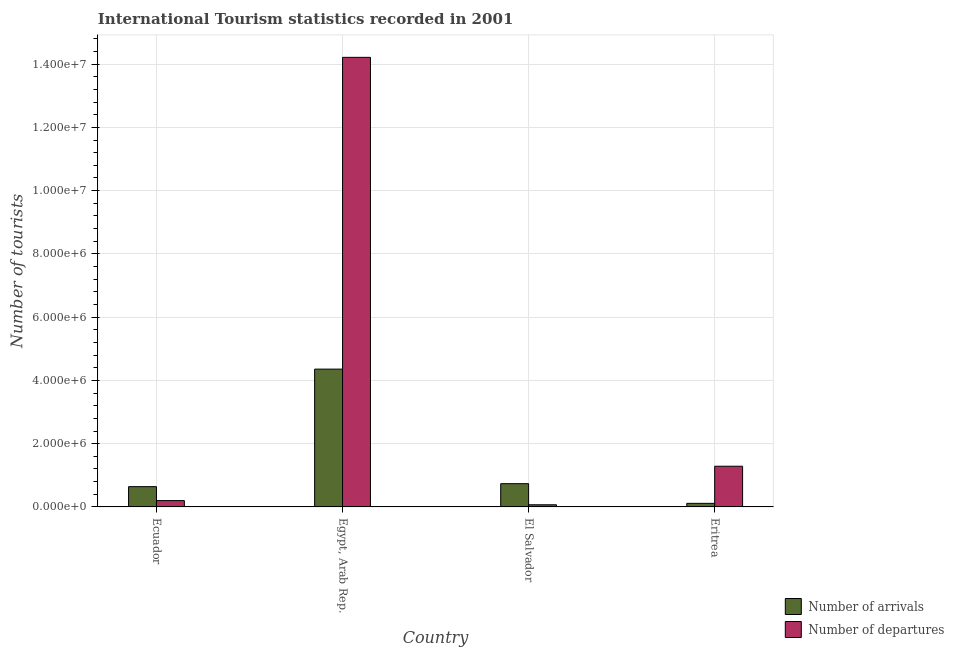How many different coloured bars are there?
Provide a succinct answer. 2. Are the number of bars on each tick of the X-axis equal?
Your answer should be compact. Yes. How many bars are there on the 4th tick from the left?
Give a very brief answer. 2. How many bars are there on the 4th tick from the right?
Make the answer very short. 2. What is the label of the 4th group of bars from the left?
Offer a terse response. Eritrea. What is the number of tourist arrivals in Ecuador?
Provide a short and direct response. 6.41e+05. Across all countries, what is the maximum number of tourist departures?
Provide a succinct answer. 1.42e+07. Across all countries, what is the minimum number of tourist arrivals?
Keep it short and to the point. 1.13e+05. In which country was the number of tourist departures maximum?
Your answer should be very brief. Egypt, Arab Rep. In which country was the number of tourist departures minimum?
Make the answer very short. El Salvador. What is the total number of tourist departures in the graph?
Make the answer very short. 1.58e+07. What is the difference between the number of tourist arrivals in Egypt, Arab Rep. and that in Eritrea?
Give a very brief answer. 4.24e+06. What is the difference between the number of tourist departures in Eritrea and the number of tourist arrivals in Egypt, Arab Rep.?
Keep it short and to the point. -3.07e+06. What is the average number of tourist arrivals per country?
Your answer should be compact. 1.46e+06. What is the difference between the number of tourist departures and number of tourist arrivals in El Salvador?
Give a very brief answer. -6.67e+05. In how many countries, is the number of tourist arrivals greater than 12400000 ?
Make the answer very short. 0. What is the ratio of the number of tourist arrivals in Egypt, Arab Rep. to that in Eritrea?
Provide a succinct answer. 38.56. Is the difference between the number of tourist arrivals in Egypt, Arab Rep. and Eritrea greater than the difference between the number of tourist departures in Egypt, Arab Rep. and Eritrea?
Make the answer very short. No. What is the difference between the highest and the second highest number of tourist departures?
Make the answer very short. 1.29e+07. What is the difference between the highest and the lowest number of tourist arrivals?
Offer a terse response. 4.24e+06. What does the 2nd bar from the left in Egypt, Arab Rep. represents?
Ensure brevity in your answer.  Number of departures. What does the 1st bar from the right in Eritrea represents?
Your response must be concise. Number of departures. How many bars are there?
Ensure brevity in your answer.  8. How many countries are there in the graph?
Provide a succinct answer. 4. Does the graph contain any zero values?
Give a very brief answer. No. Does the graph contain grids?
Ensure brevity in your answer.  Yes. How many legend labels are there?
Offer a very short reply. 2. How are the legend labels stacked?
Offer a very short reply. Vertical. What is the title of the graph?
Provide a succinct answer. International Tourism statistics recorded in 2001. Does "From production" appear as one of the legend labels in the graph?
Provide a short and direct response. No. What is the label or title of the Y-axis?
Ensure brevity in your answer.  Number of tourists. What is the Number of tourists in Number of arrivals in Ecuador?
Ensure brevity in your answer.  6.41e+05. What is the Number of tourists in Number of arrivals in Egypt, Arab Rep.?
Your response must be concise. 4.36e+06. What is the Number of tourists in Number of departures in Egypt, Arab Rep.?
Your response must be concise. 1.42e+07. What is the Number of tourists in Number of arrivals in El Salvador?
Offer a very short reply. 7.35e+05. What is the Number of tourists in Number of departures in El Salvador?
Your answer should be compact. 6.80e+04. What is the Number of tourists in Number of arrivals in Eritrea?
Give a very brief answer. 1.13e+05. What is the Number of tourists in Number of departures in Eritrea?
Offer a very short reply. 1.29e+06. Across all countries, what is the maximum Number of tourists in Number of arrivals?
Keep it short and to the point. 4.36e+06. Across all countries, what is the maximum Number of tourists of Number of departures?
Give a very brief answer. 1.42e+07. Across all countries, what is the minimum Number of tourists of Number of arrivals?
Make the answer very short. 1.13e+05. Across all countries, what is the minimum Number of tourists of Number of departures?
Provide a short and direct response. 6.80e+04. What is the total Number of tourists of Number of arrivals in the graph?
Offer a very short reply. 5.85e+06. What is the total Number of tourists in Number of departures in the graph?
Offer a very short reply. 1.58e+07. What is the difference between the Number of tourists of Number of arrivals in Ecuador and that in Egypt, Arab Rep.?
Your answer should be compact. -3.72e+06. What is the difference between the Number of tourists of Number of departures in Ecuador and that in Egypt, Arab Rep.?
Your response must be concise. -1.40e+07. What is the difference between the Number of tourists in Number of arrivals in Ecuador and that in El Salvador?
Make the answer very short. -9.40e+04. What is the difference between the Number of tourists of Number of departures in Ecuador and that in El Salvador?
Ensure brevity in your answer.  1.32e+05. What is the difference between the Number of tourists in Number of arrivals in Ecuador and that in Eritrea?
Offer a very short reply. 5.28e+05. What is the difference between the Number of tourists of Number of departures in Ecuador and that in Eritrea?
Keep it short and to the point. -1.09e+06. What is the difference between the Number of tourists of Number of arrivals in Egypt, Arab Rep. and that in El Salvador?
Your answer should be very brief. 3.62e+06. What is the difference between the Number of tourists of Number of departures in Egypt, Arab Rep. and that in El Salvador?
Offer a very short reply. 1.41e+07. What is the difference between the Number of tourists in Number of arrivals in Egypt, Arab Rep. and that in Eritrea?
Provide a succinct answer. 4.24e+06. What is the difference between the Number of tourists in Number of departures in Egypt, Arab Rep. and that in Eritrea?
Your answer should be very brief. 1.29e+07. What is the difference between the Number of tourists of Number of arrivals in El Salvador and that in Eritrea?
Provide a succinct answer. 6.22e+05. What is the difference between the Number of tourists in Number of departures in El Salvador and that in Eritrea?
Your answer should be compact. -1.22e+06. What is the difference between the Number of tourists in Number of arrivals in Ecuador and the Number of tourists in Number of departures in Egypt, Arab Rep.?
Make the answer very short. -1.36e+07. What is the difference between the Number of tourists of Number of arrivals in Ecuador and the Number of tourists of Number of departures in El Salvador?
Provide a short and direct response. 5.73e+05. What is the difference between the Number of tourists of Number of arrivals in Ecuador and the Number of tourists of Number of departures in Eritrea?
Offer a terse response. -6.46e+05. What is the difference between the Number of tourists in Number of arrivals in Egypt, Arab Rep. and the Number of tourists in Number of departures in El Salvador?
Give a very brief answer. 4.29e+06. What is the difference between the Number of tourists in Number of arrivals in Egypt, Arab Rep. and the Number of tourists in Number of departures in Eritrea?
Your answer should be compact. 3.07e+06. What is the difference between the Number of tourists of Number of arrivals in El Salvador and the Number of tourists of Number of departures in Eritrea?
Provide a succinct answer. -5.52e+05. What is the average Number of tourists of Number of arrivals per country?
Your answer should be compact. 1.46e+06. What is the average Number of tourists in Number of departures per country?
Ensure brevity in your answer.  3.94e+06. What is the difference between the Number of tourists in Number of arrivals and Number of tourists in Number of departures in Ecuador?
Make the answer very short. 4.41e+05. What is the difference between the Number of tourists of Number of arrivals and Number of tourists of Number of departures in Egypt, Arab Rep.?
Your response must be concise. -9.86e+06. What is the difference between the Number of tourists in Number of arrivals and Number of tourists in Number of departures in El Salvador?
Ensure brevity in your answer.  6.67e+05. What is the difference between the Number of tourists in Number of arrivals and Number of tourists in Number of departures in Eritrea?
Provide a succinct answer. -1.17e+06. What is the ratio of the Number of tourists in Number of arrivals in Ecuador to that in Egypt, Arab Rep.?
Give a very brief answer. 0.15. What is the ratio of the Number of tourists of Number of departures in Ecuador to that in Egypt, Arab Rep.?
Give a very brief answer. 0.01. What is the ratio of the Number of tourists in Number of arrivals in Ecuador to that in El Salvador?
Ensure brevity in your answer.  0.87. What is the ratio of the Number of tourists of Number of departures in Ecuador to that in El Salvador?
Give a very brief answer. 2.94. What is the ratio of the Number of tourists in Number of arrivals in Ecuador to that in Eritrea?
Your answer should be compact. 5.67. What is the ratio of the Number of tourists in Number of departures in Ecuador to that in Eritrea?
Your answer should be compact. 0.16. What is the ratio of the Number of tourists of Number of arrivals in Egypt, Arab Rep. to that in El Salvador?
Your response must be concise. 5.93. What is the ratio of the Number of tourists of Number of departures in Egypt, Arab Rep. to that in El Salvador?
Provide a succinct answer. 209.03. What is the ratio of the Number of tourists of Number of arrivals in Egypt, Arab Rep. to that in Eritrea?
Your response must be concise. 38.56. What is the ratio of the Number of tourists of Number of departures in Egypt, Arab Rep. to that in Eritrea?
Offer a terse response. 11.04. What is the ratio of the Number of tourists of Number of arrivals in El Salvador to that in Eritrea?
Ensure brevity in your answer.  6.5. What is the ratio of the Number of tourists of Number of departures in El Salvador to that in Eritrea?
Offer a very short reply. 0.05. What is the difference between the highest and the second highest Number of tourists in Number of arrivals?
Your answer should be very brief. 3.62e+06. What is the difference between the highest and the second highest Number of tourists in Number of departures?
Provide a short and direct response. 1.29e+07. What is the difference between the highest and the lowest Number of tourists of Number of arrivals?
Your answer should be very brief. 4.24e+06. What is the difference between the highest and the lowest Number of tourists of Number of departures?
Ensure brevity in your answer.  1.41e+07. 